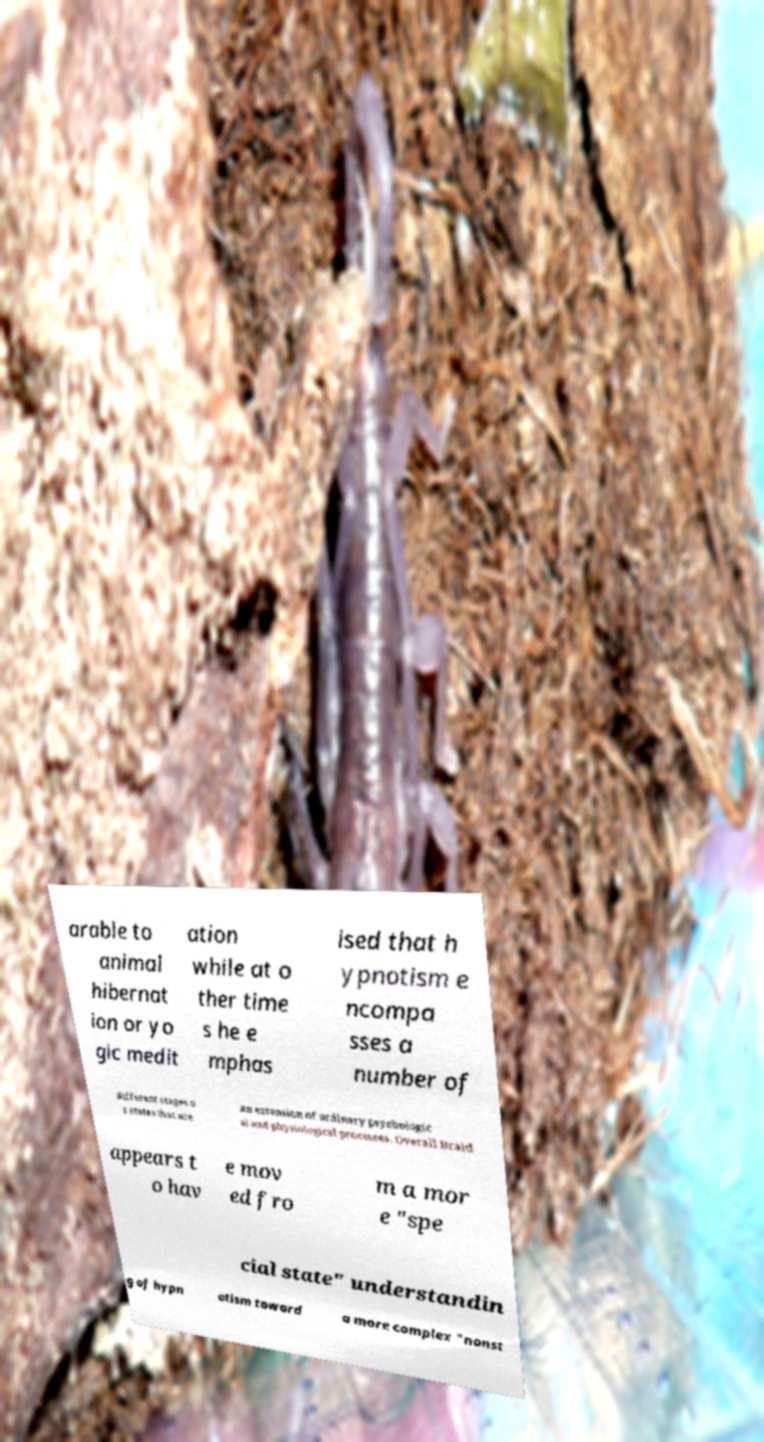For documentation purposes, I need the text within this image transcribed. Could you provide that? arable to animal hibernat ion or yo gic medit ation while at o ther time s he e mphas ised that h ypnotism e ncompa sses a number of different stages o r states that are an extension of ordinary psychologic al and physiological processes. Overall Braid appears t o hav e mov ed fro m a mor e "spe cial state" understandin g of hypn otism toward a more complex "nonst 